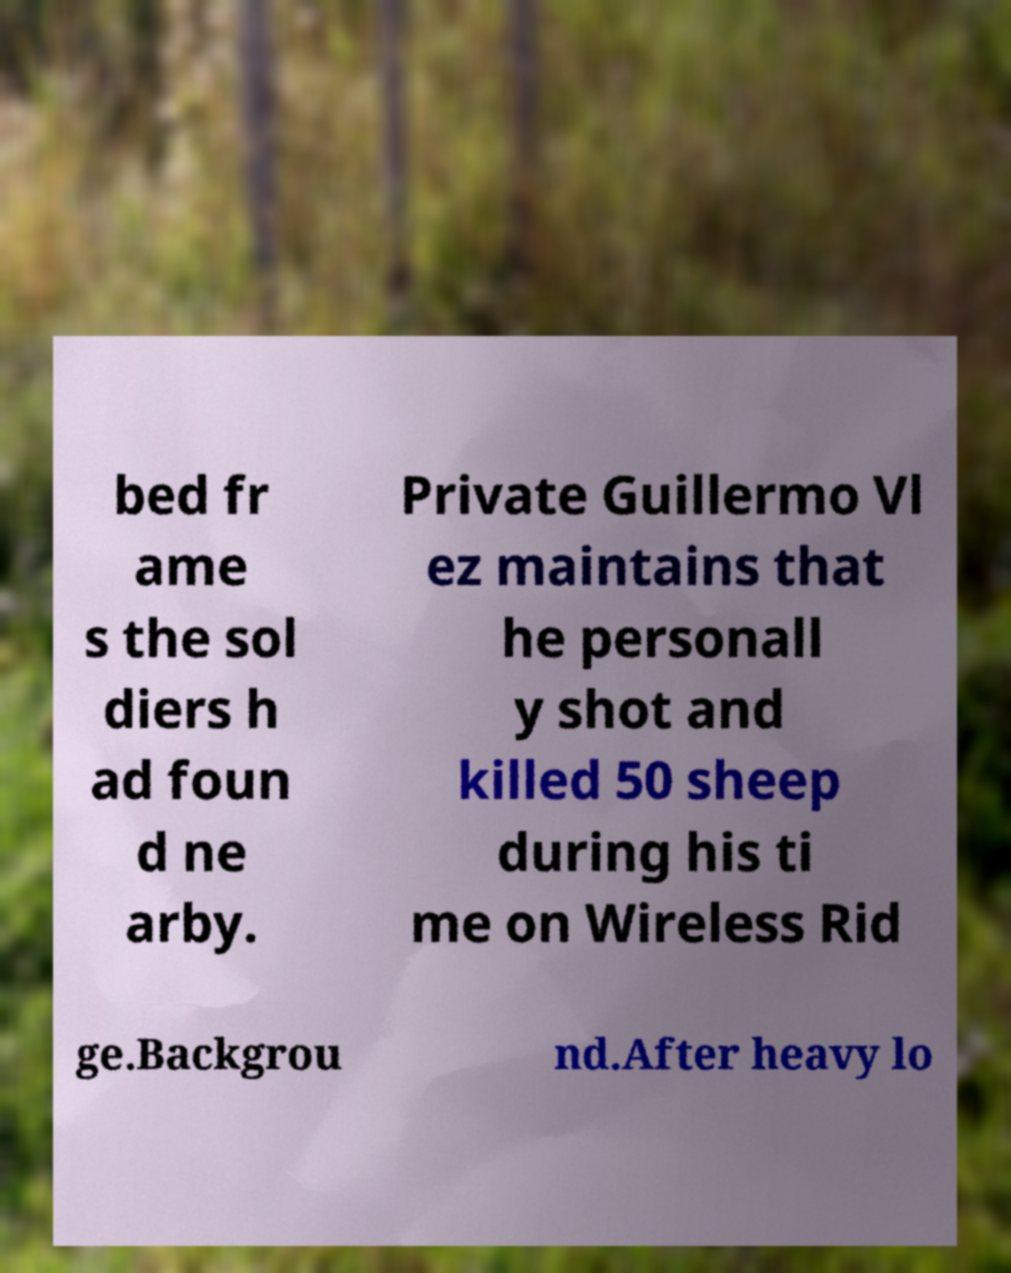I need the written content from this picture converted into text. Can you do that? bed fr ame s the sol diers h ad foun d ne arby. Private Guillermo Vl ez maintains that he personall y shot and killed 50 sheep during his ti me on Wireless Rid ge.Backgrou nd.After heavy lo 